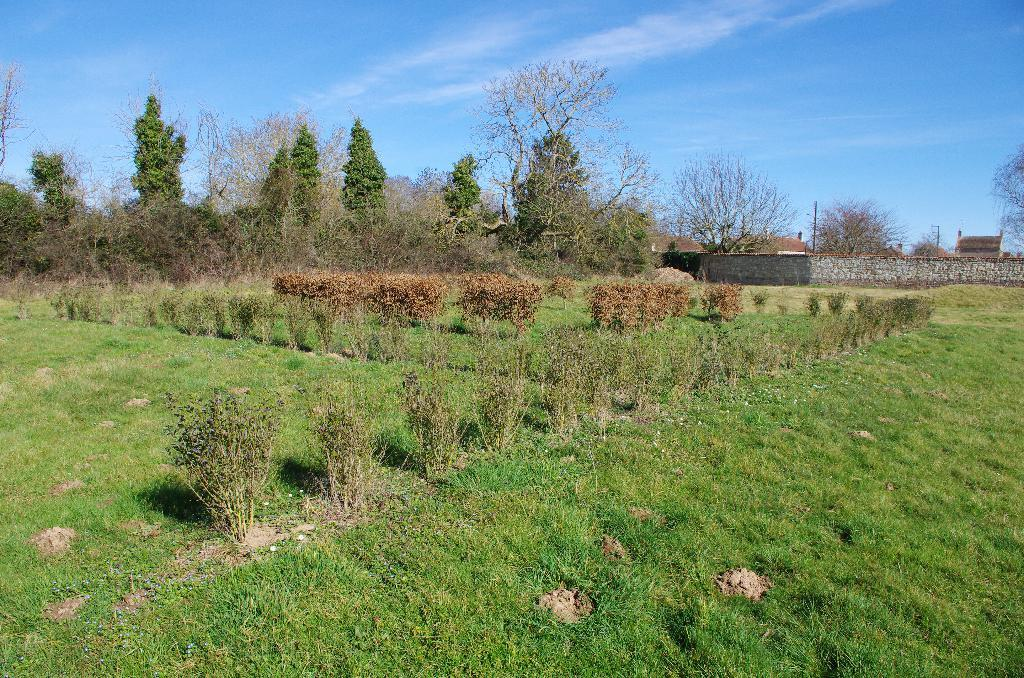What is located in the middle of the image? There are plants in the middle of the image. What can be seen in the background of the image? There are trees in the background of the image. What is on the right side of the image? There is a wall on the right side of the image. What is visible at the top of the image? The sky is visible at the top of the image. How many units of death can be seen in the image? There is no reference to death or units in the image, so it is not possible to answer that question. 